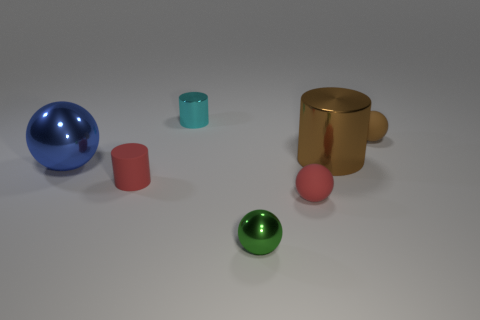The object that is the same color as the tiny rubber cylinder is what shape?
Keep it short and to the point. Sphere. What color is the other big shiny thing that is the same shape as the cyan thing?
Offer a terse response. Brown. There is a red object that is on the right side of the small red matte cylinder; does it have the same size as the object behind the small brown rubber thing?
Your answer should be compact. Yes. Are there any red matte things of the same shape as the large brown object?
Give a very brief answer. Yes. Are there the same number of small metallic objects right of the tiny brown rubber object and small matte cylinders?
Offer a terse response. No. There is a blue shiny thing; is its size the same as the red matte object right of the green metallic ball?
Your answer should be compact. No. What number of big blue balls are the same material as the brown cylinder?
Provide a succinct answer. 1. Is the size of the brown shiny thing the same as the red rubber sphere?
Give a very brief answer. No. Is there any other thing that is the same color as the small metal cylinder?
Make the answer very short. No. There is a small matte object that is both to the right of the tiny red rubber cylinder and behind the tiny red sphere; what shape is it?
Keep it short and to the point. Sphere. 